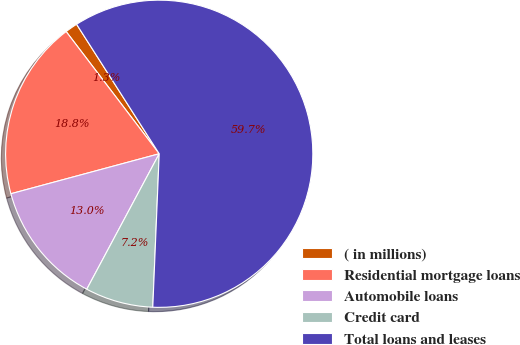Convert chart to OTSL. <chart><loc_0><loc_0><loc_500><loc_500><pie_chart><fcel>( in millions)<fcel>Residential mortgage loans<fcel>Automobile loans<fcel>Credit card<fcel>Total loans and leases<nl><fcel>1.32%<fcel>18.83%<fcel>12.99%<fcel>7.15%<fcel>59.7%<nl></chart> 